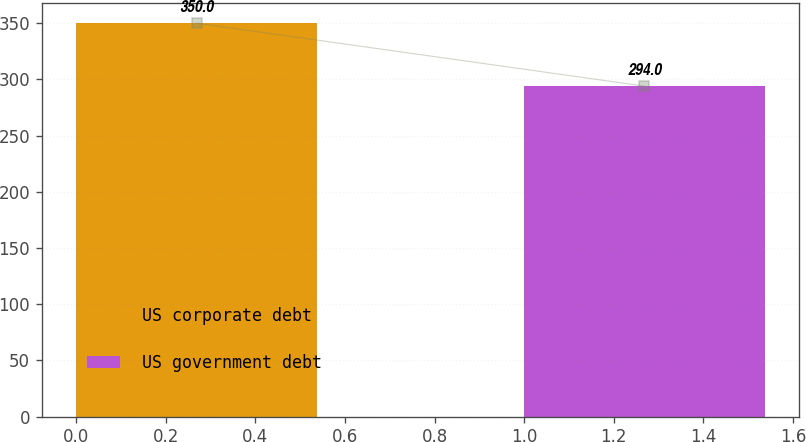<chart> <loc_0><loc_0><loc_500><loc_500><bar_chart><fcel>US corporate debt<fcel>US government debt<nl><fcel>350<fcel>294<nl></chart> 